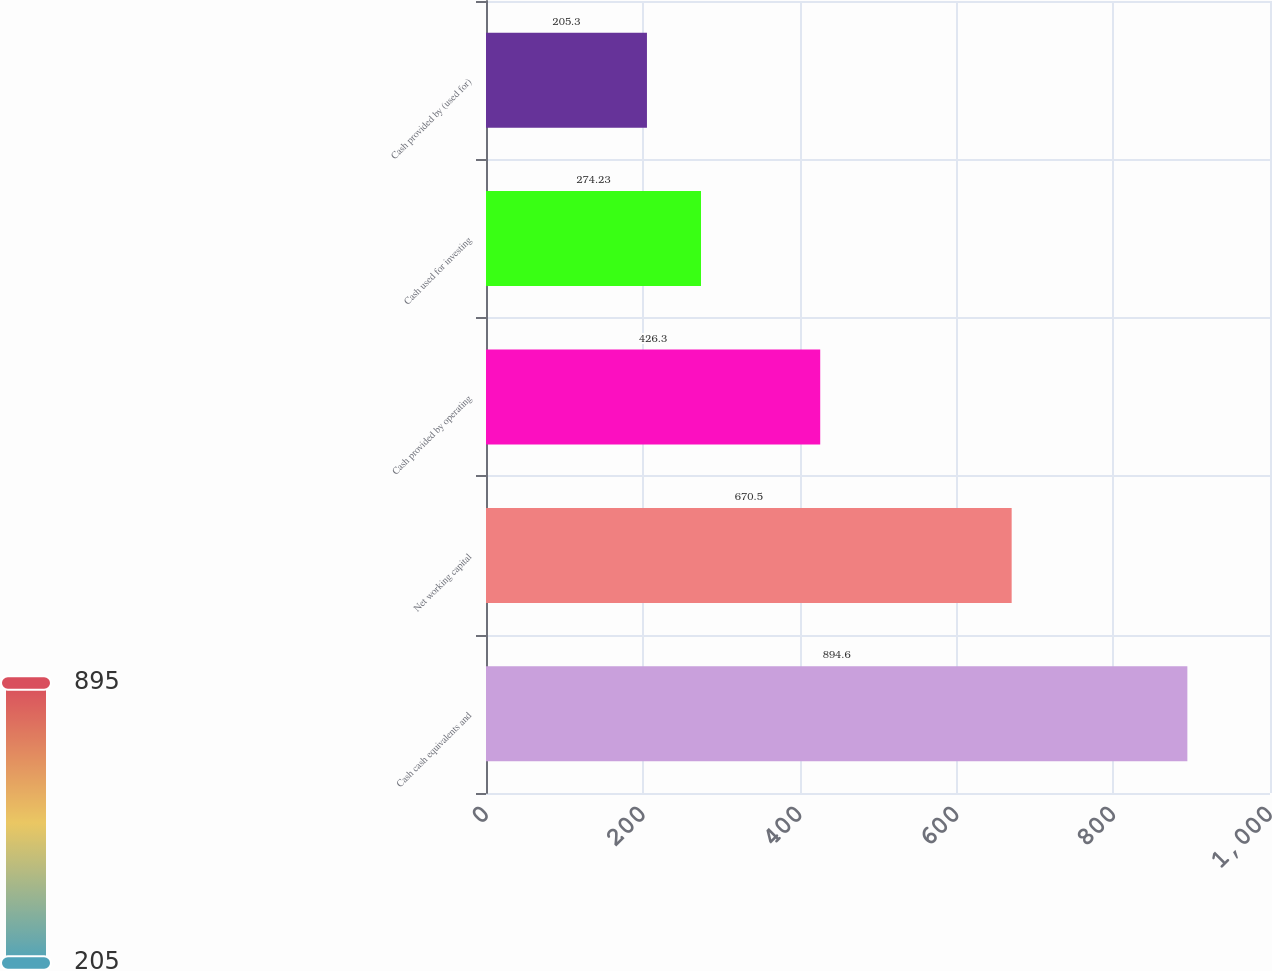Convert chart. <chart><loc_0><loc_0><loc_500><loc_500><bar_chart><fcel>Cash cash equivalents and<fcel>Net working capital<fcel>Cash provided by operating<fcel>Cash used for investing<fcel>Cash provided by (used for)<nl><fcel>894.6<fcel>670.5<fcel>426.3<fcel>274.23<fcel>205.3<nl></chart> 